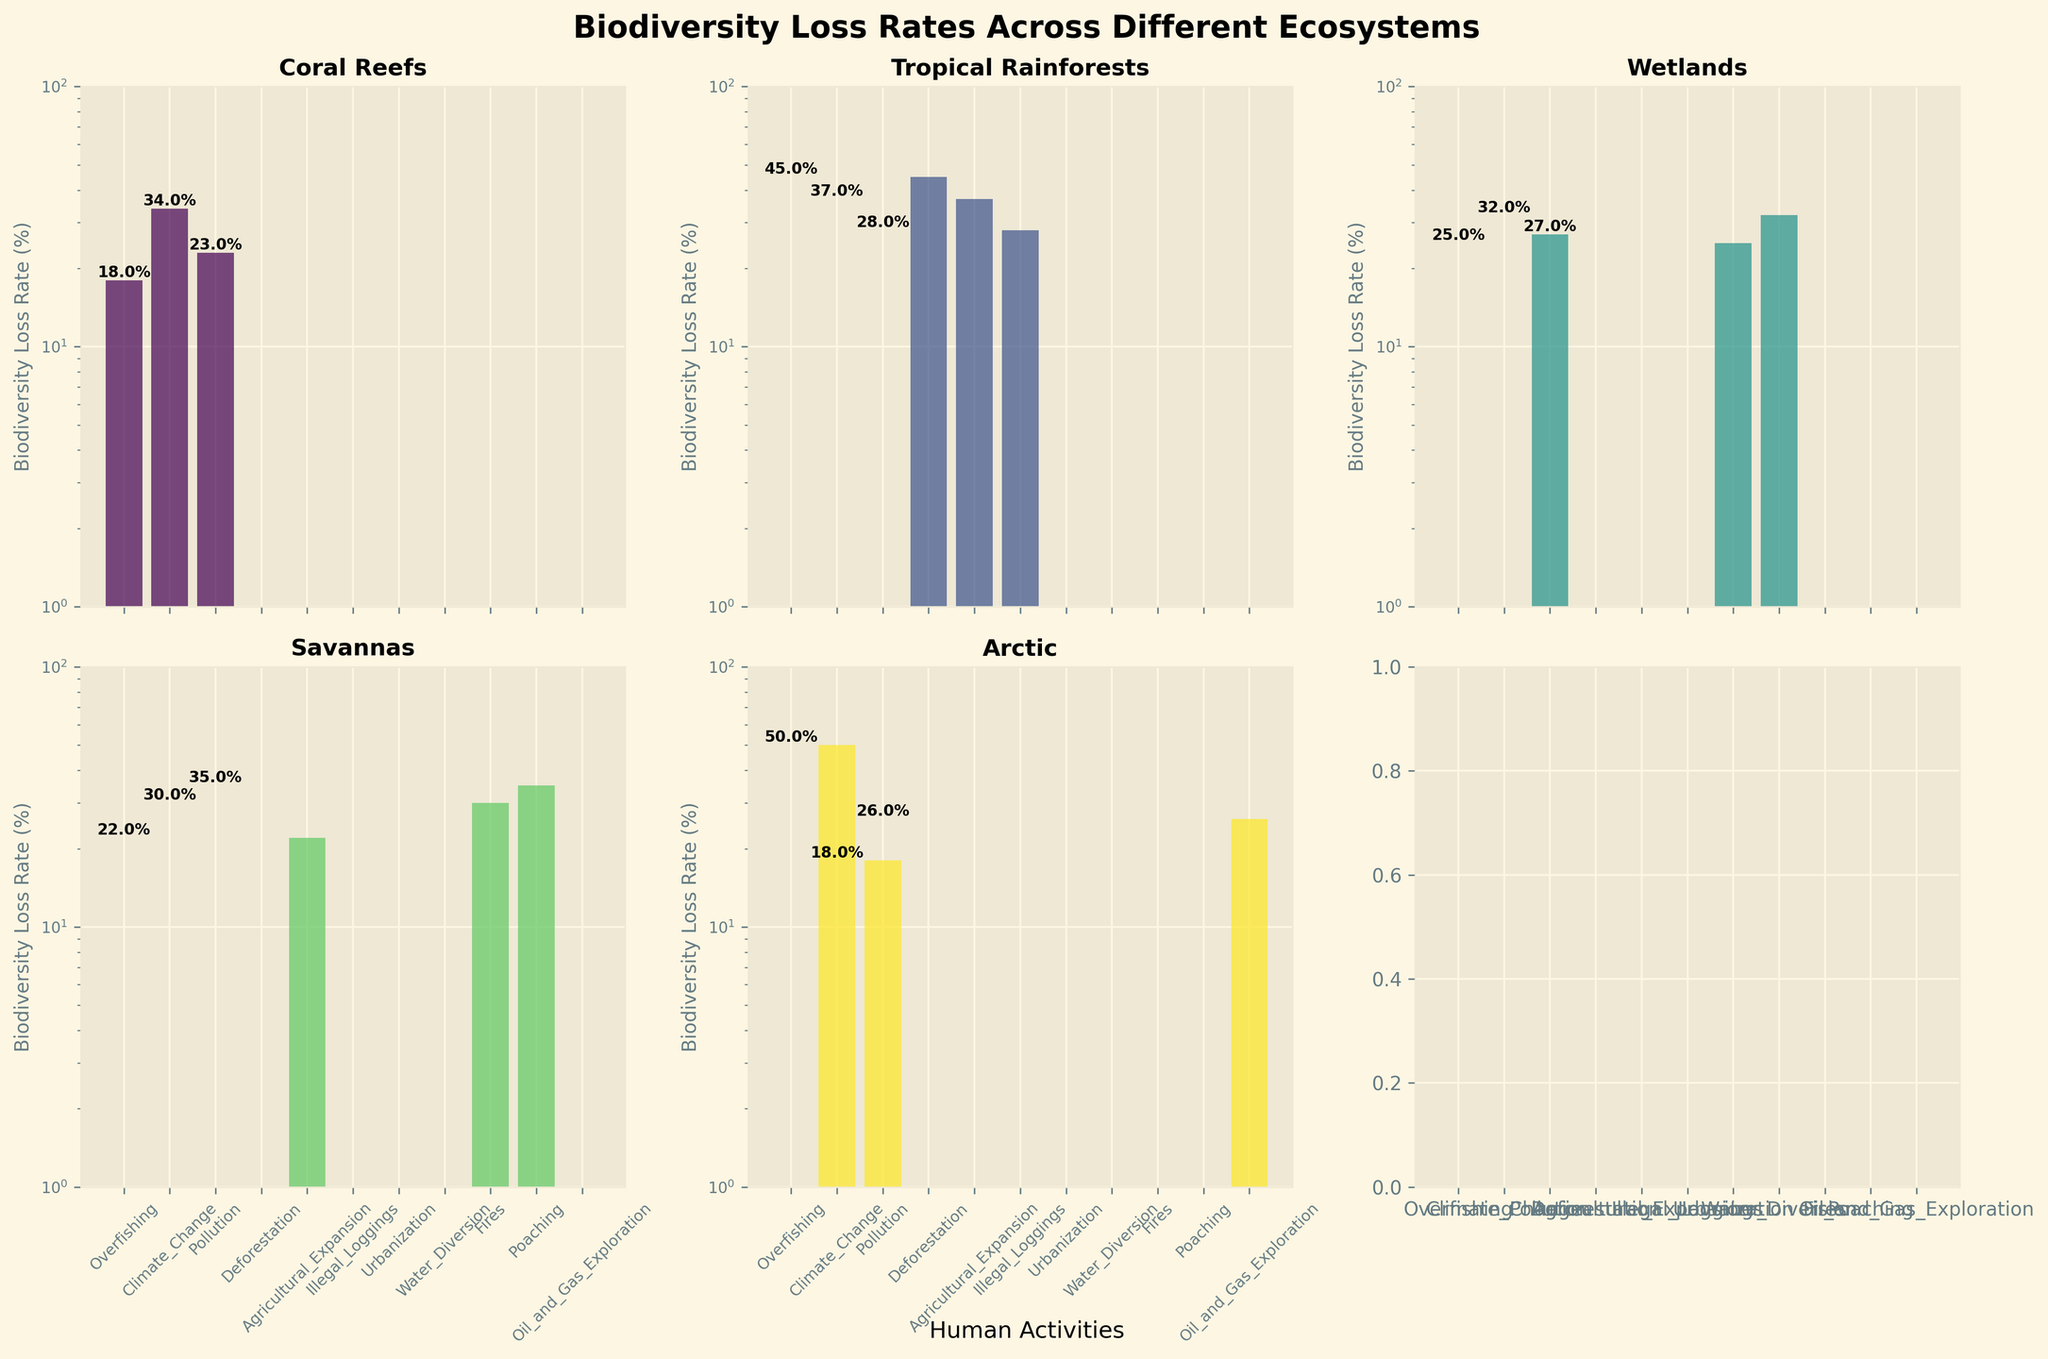What is the title of the figure? The title of the figure is displayed at the top as "Biodiversity Loss Rates Across Different Ecosystems".
Answer: Biodiversity Loss Rates Across Different Ecosystems What is the y-axis label in each subplot? The y-axis label in each subplot is "Biodiversity Loss Rate (%)". You can see this indicated near the y-axis for each ecosystem.
Answer: Biodiversity Loss Rate (%) Which ecosystem has the highest reported biodiversity loss rate, and what is the corresponding human activity? By looking at the figure, for the Arctic ecosystem, the highest loss rate is 50%, which is due to Climate Change.
Answer: Arctic, Climate Change Out of Coral Reefs and Wetlands, which ecosystem has a broader range of biodiversity loss rates? Coral Reefs have a broader range from 18% to 34% while Wetlands range from 25% to 32%.
Answer: Coral Reefs In which ecosystems does pollution cause biodiversity loss, and what are the respective loss rates? Pollution causes biodiversity loss in Coral Reefs (23%), Wetlands (27%), and Arctic (18%). This can be verified by looking at the subplots for each ecosystem.
Answer: Coral Reefs: 23%, Wetlands: 27%, Arctic: 18% For the ecosystem with the lowest biodiversity loss rate, what is the human activity responsible, and what ecosystem is it? The lowest biodiversity loss rate (18%) is associated with Pollution in the Arctic ecosystem. This can be identified from examining all the bars across the subplots.
Answer: Arctic, Pollution Between Agricultural Expansion in Tropical Rainforests and Savannas, which has a higher biodiversity loss rate? Agricultural Expansion in Savannas has a biodiversity loss rate of 22%, while in Tropical Rainforests, it is 37%. Thus, the rate is higher in Tropical Rainforests.
Answer: Tropical Rainforests What is the combined biodiversity loss rate for all activities in the Wetlands ecosystem? Summing the loss rates for Wetlands: 25% (Urbanization) + 32% (Water Diversion) + 27% (Pollution) gives a total of 84%.
Answer: 84% How many ecosystems have biodiversity loss caused by Climate Change, and what are their respective rates? Climate Change causes biodiversity loss in Coral Reefs (34%), and Arctic (50%). By examining the subplots, these are the only two ecosystems affected.
Answer: 2; Coral Reefs: 34%, Arctic: 50% What is the range of biodiversity loss rates reported for Tropical Rainforests? The range can be calculated by finding the difference between the highest (Deforestation - 45%) and lowest (Illegal Loggings - 28%) rates: 45% - 28% = 17%.
Answer: 17% 